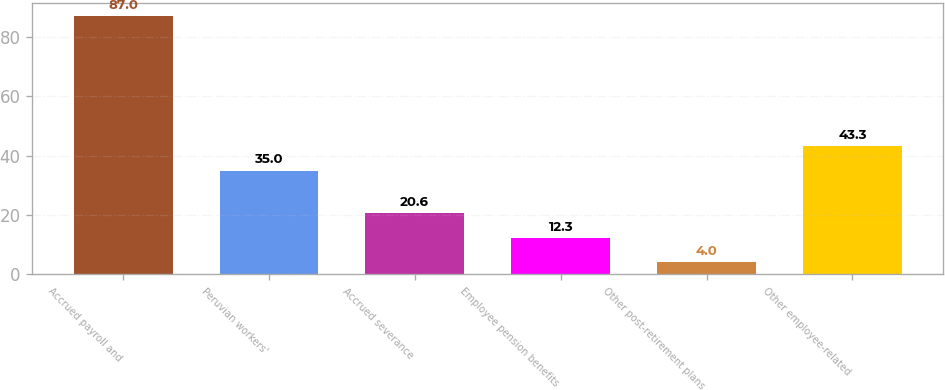<chart> <loc_0><loc_0><loc_500><loc_500><bar_chart><fcel>Accrued payroll and<fcel>Peruvian workers'<fcel>Accrued severance<fcel>Employee pension benefits<fcel>Other post-retirement plans<fcel>Other employee-related<nl><fcel>87<fcel>35<fcel>20.6<fcel>12.3<fcel>4<fcel>43.3<nl></chart> 